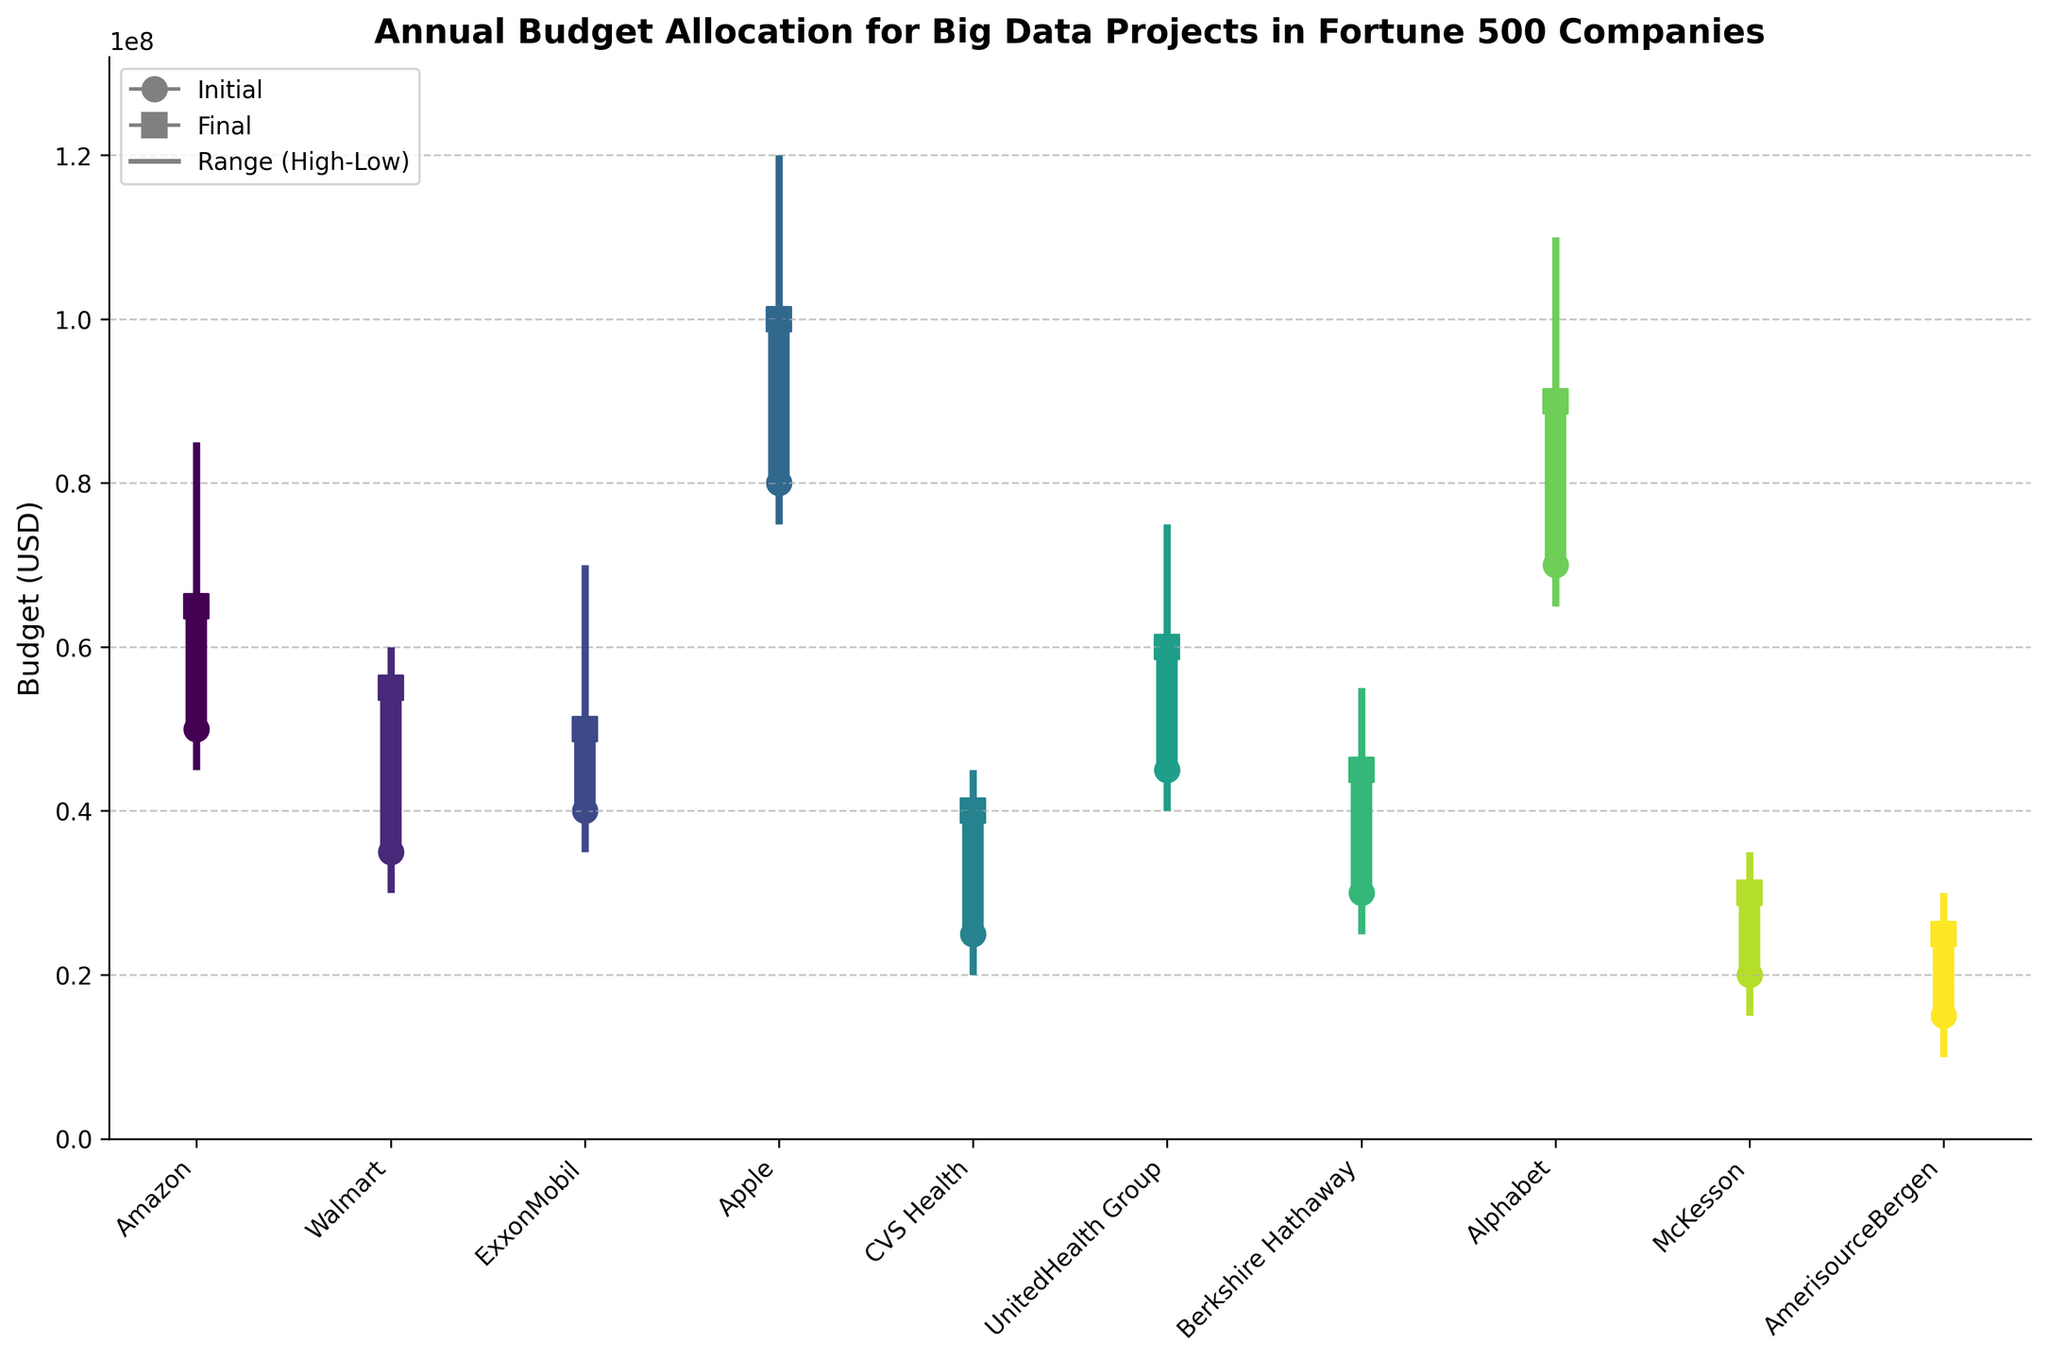what is the title of the figure? The title is usually placed at the top of the chart for easy identification. It summarizes the purpose or contents of the figure. In this case, the title is "Annual Budget Allocation for Big Data Projects in Fortune 500 Companies".
Answer: Annual Budget Allocation for Big Data Projects in Fortune 500 Companies Which company had the highest initial budget allocation? To answer this, look at the initial budget indicators (circles) and identify the highest value among them. The highest initial budget circle is for Apple, which is $80,000,000.
Answer: Apple What is the range of the budget for Alphabet? The range is calculated as the difference between the highest and lowest budgets. For Alphabet, the highest budget is $110,000,000 and the lowest is $65,000,000. So, the range is $110,000,000 - $65,000,000 = $45,000,000.
Answer: $45,000,000 How does Amazon's final budget compare to Walmart's highest budget? By comparing the final budget of Amazon ($65,000,000) with Walmart's highest budget ($60,000,000), we determine that Amazon's final budget is $5,000,000 higher than Walmart's highest budget.
Answer: Amazon's final budget is higher Which company experienced the largest decrease in budget from the highest to the lowest value? To determine which company had the largest decrease, subtract the lowest budget from the highest budget for each company. For ExxonMobil, it is $70,000,000 - $35,000,000 = $35,000,000. This is the largest decrease observed amongst the companies.
Answer: ExxonMobil What is the average final budget for all the companies listed? Add up all the final budgets and divide by the number of companies. The total is: $65,000,000 + $55,000,000 + $50,000,000 + $100,000,000 + $40,000,000 + $60,000,000 + $45,000,000 + $90,000,000 + $30,000,000 + $25,000,000 = $560,000,000. There are 10 companies, so the average is $560,000,000 / 10 = $56,000,000.
Answer: $56,000,000 Between CVS Health and McKesson, which company had a higher lowest budget? Compare the lowest budget values directly. CVS Health's lowest budget is $20,000,000 while McKesson's is $15,000,000. Thus, CVS Health had a higher lowest budget.
Answer: CVS Health What is the total initial budget for Amazon, UnitedHealth Group, and Alphabet combined? Sum the initial budgets of the mentioned companies. Amazon's initial budget is $50,000,000, UnitedHealth Group's is $45,000,000, and Alphabet's is $70,000,000. So the total initial budget is $50,000,000 + $45,000,000 + $70,000,000 = $165,000,000.
Answer: $165,000,000 